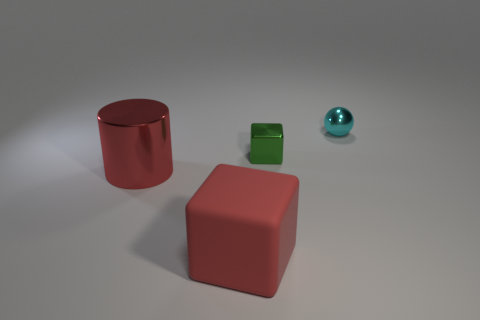Add 2 large red metal cylinders. How many objects exist? 6 Subtract all spheres. How many objects are left? 3 Add 1 large red cylinders. How many large red cylinders are left? 2 Add 1 green rubber spheres. How many green rubber spheres exist? 1 Subtract 1 red cylinders. How many objects are left? 3 Subtract all small spheres. Subtract all cyan cylinders. How many objects are left? 3 